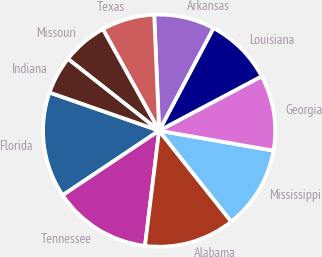Convert chart. <chart><loc_0><loc_0><loc_500><loc_500><pie_chart><fcel>Florida<fcel>Tennessee<fcel>Alabama<fcel>Mississippi<fcel>Georgia<fcel>Louisiana<fcel>Arkansas<fcel>Texas<fcel>Missouri<fcel>Indiana<nl><fcel>14.72%<fcel>13.67%<fcel>12.62%<fcel>11.57%<fcel>10.52%<fcel>9.48%<fcel>8.43%<fcel>7.38%<fcel>6.33%<fcel>5.28%<nl></chart> 